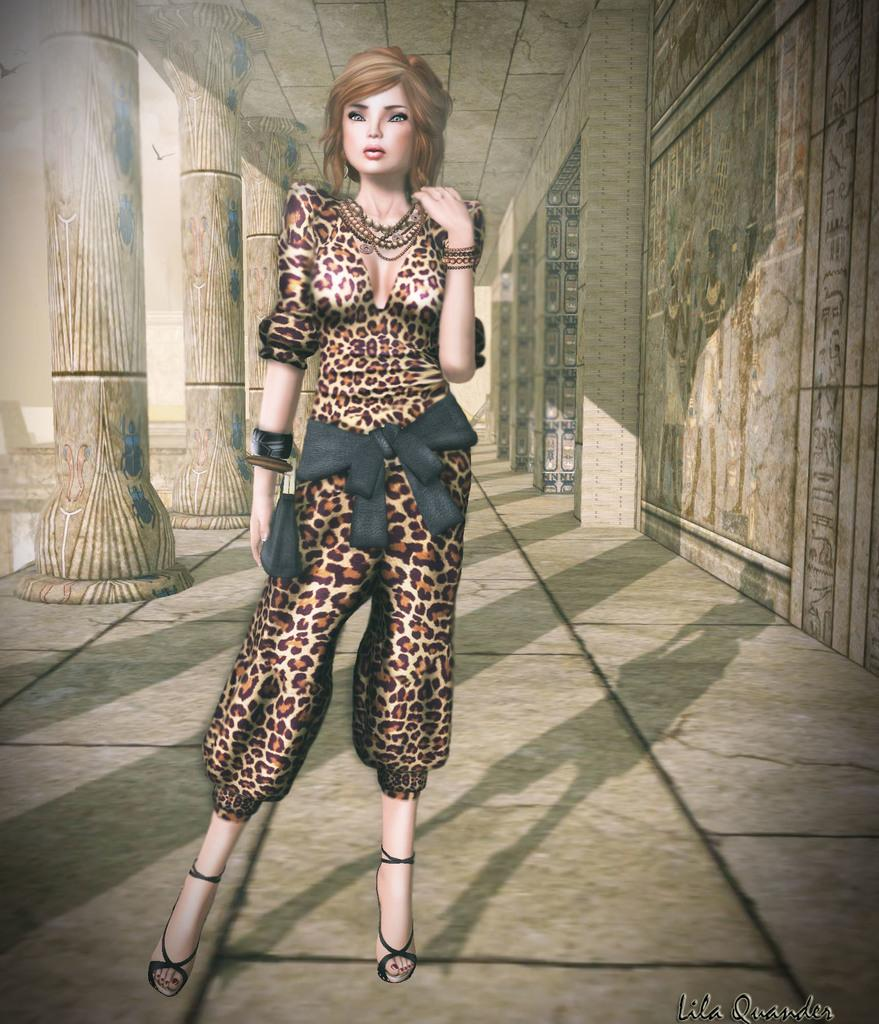What type of image is being described? The image is animated. Can you describe the person in the image? The person in the image is wearing a black and brown color dress. What can be seen on the left side of the person? There are pillars to the left of the person. What is on the right side of the person? There is a wall to the right of the person. Is the person wearing a crown in the image? No, the person is not wearing a crown in the image. What type of emotion is the person expressing in the image? The provided facts do not mention any emotions or expressions of the person, so it cannot be determined from the image. 